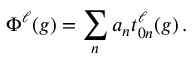Convert formula to latex. <formula><loc_0><loc_0><loc_500><loc_500>\Phi ^ { \ell } ( g ) = \sum _ { n } a _ { n } t _ { 0 n } ^ { \ell } ( g ) \, .</formula> 